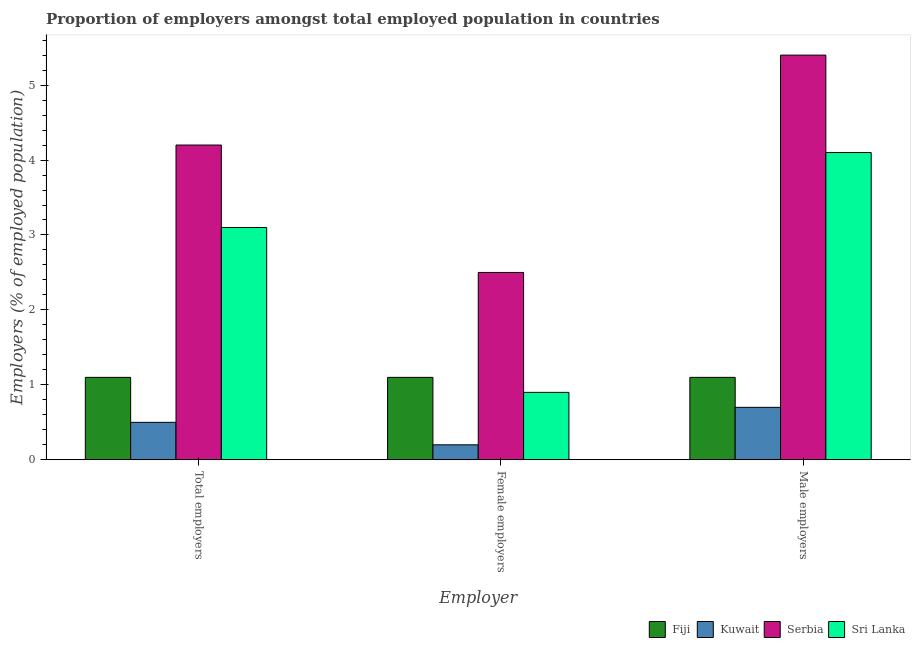How many groups of bars are there?
Your response must be concise. 3. Are the number of bars on each tick of the X-axis equal?
Offer a terse response. Yes. How many bars are there on the 2nd tick from the left?
Provide a succinct answer. 4. How many bars are there on the 1st tick from the right?
Offer a terse response. 4. What is the label of the 2nd group of bars from the left?
Your response must be concise. Female employers. What is the percentage of female employers in Sri Lanka?
Your answer should be very brief. 0.9. Across all countries, what is the minimum percentage of female employers?
Ensure brevity in your answer.  0.2. In which country was the percentage of male employers maximum?
Provide a succinct answer. Serbia. In which country was the percentage of total employers minimum?
Your answer should be compact. Kuwait. What is the total percentage of male employers in the graph?
Ensure brevity in your answer.  11.3. What is the difference between the percentage of female employers in Kuwait and that in Sri Lanka?
Offer a very short reply. -0.7. What is the difference between the percentage of female employers in Fiji and the percentage of male employers in Serbia?
Provide a succinct answer. -4.3. What is the average percentage of total employers per country?
Your answer should be compact. 2.22. What is the difference between the percentage of total employers and percentage of female employers in Fiji?
Offer a very short reply. 0. In how many countries, is the percentage of male employers greater than 1.4 %?
Give a very brief answer. 2. What is the ratio of the percentage of total employers in Serbia to that in Sri Lanka?
Offer a terse response. 1.35. Is the percentage of female employers in Fiji less than that in Serbia?
Your response must be concise. Yes. What is the difference between the highest and the second highest percentage of female employers?
Offer a very short reply. 1.4. What is the difference between the highest and the lowest percentage of female employers?
Keep it short and to the point. 2.3. Is the sum of the percentage of total employers in Serbia and Kuwait greater than the maximum percentage of male employers across all countries?
Your answer should be compact. No. What does the 1st bar from the left in Male employers represents?
Provide a short and direct response. Fiji. What does the 3rd bar from the right in Total employers represents?
Your answer should be very brief. Kuwait. Are all the bars in the graph horizontal?
Your answer should be very brief. No. How many countries are there in the graph?
Your answer should be very brief. 4. What is the difference between two consecutive major ticks on the Y-axis?
Offer a very short reply. 1. Are the values on the major ticks of Y-axis written in scientific E-notation?
Your answer should be compact. No. Does the graph contain any zero values?
Offer a terse response. No. Does the graph contain grids?
Offer a terse response. No. How are the legend labels stacked?
Provide a succinct answer. Horizontal. What is the title of the graph?
Your response must be concise. Proportion of employers amongst total employed population in countries. What is the label or title of the X-axis?
Provide a short and direct response. Employer. What is the label or title of the Y-axis?
Offer a very short reply. Employers (% of employed population). What is the Employers (% of employed population) in Fiji in Total employers?
Provide a succinct answer. 1.1. What is the Employers (% of employed population) in Kuwait in Total employers?
Offer a terse response. 0.5. What is the Employers (% of employed population) in Serbia in Total employers?
Ensure brevity in your answer.  4.2. What is the Employers (% of employed population) in Sri Lanka in Total employers?
Keep it short and to the point. 3.1. What is the Employers (% of employed population) in Fiji in Female employers?
Offer a terse response. 1.1. What is the Employers (% of employed population) in Kuwait in Female employers?
Provide a succinct answer. 0.2. What is the Employers (% of employed population) of Serbia in Female employers?
Offer a terse response. 2.5. What is the Employers (% of employed population) in Sri Lanka in Female employers?
Your answer should be compact. 0.9. What is the Employers (% of employed population) of Fiji in Male employers?
Offer a terse response. 1.1. What is the Employers (% of employed population) of Kuwait in Male employers?
Your answer should be compact. 0.7. What is the Employers (% of employed population) of Serbia in Male employers?
Your answer should be compact. 5.4. What is the Employers (% of employed population) in Sri Lanka in Male employers?
Give a very brief answer. 4.1. Across all Employer, what is the maximum Employers (% of employed population) in Fiji?
Your answer should be very brief. 1.1. Across all Employer, what is the maximum Employers (% of employed population) of Kuwait?
Give a very brief answer. 0.7. Across all Employer, what is the maximum Employers (% of employed population) of Serbia?
Offer a very short reply. 5.4. Across all Employer, what is the maximum Employers (% of employed population) of Sri Lanka?
Your answer should be compact. 4.1. Across all Employer, what is the minimum Employers (% of employed population) in Fiji?
Your response must be concise. 1.1. Across all Employer, what is the minimum Employers (% of employed population) in Kuwait?
Provide a succinct answer. 0.2. Across all Employer, what is the minimum Employers (% of employed population) of Sri Lanka?
Keep it short and to the point. 0.9. What is the total Employers (% of employed population) of Fiji in the graph?
Give a very brief answer. 3.3. What is the total Employers (% of employed population) in Kuwait in the graph?
Your response must be concise. 1.4. What is the difference between the Employers (% of employed population) of Kuwait in Total employers and that in Female employers?
Your answer should be compact. 0.3. What is the difference between the Employers (% of employed population) in Fiji in Total employers and that in Male employers?
Ensure brevity in your answer.  0. What is the difference between the Employers (% of employed population) in Sri Lanka in Total employers and that in Male employers?
Provide a short and direct response. -1. What is the difference between the Employers (% of employed population) of Fiji in Total employers and the Employers (% of employed population) of Kuwait in Female employers?
Your answer should be very brief. 0.9. What is the difference between the Employers (% of employed population) in Fiji in Total employers and the Employers (% of employed population) in Sri Lanka in Female employers?
Provide a succinct answer. 0.2. What is the difference between the Employers (% of employed population) in Kuwait in Total employers and the Employers (% of employed population) in Sri Lanka in Female employers?
Give a very brief answer. -0.4. What is the difference between the Employers (% of employed population) of Serbia in Total employers and the Employers (% of employed population) of Sri Lanka in Female employers?
Offer a very short reply. 3.3. What is the difference between the Employers (% of employed population) in Kuwait in Total employers and the Employers (% of employed population) in Sri Lanka in Male employers?
Offer a terse response. -3.6. What is the difference between the Employers (% of employed population) of Serbia in Total employers and the Employers (% of employed population) of Sri Lanka in Male employers?
Your answer should be very brief. 0.1. What is the difference between the Employers (% of employed population) of Fiji in Female employers and the Employers (% of employed population) of Kuwait in Male employers?
Keep it short and to the point. 0.4. What is the difference between the Employers (% of employed population) of Fiji in Female employers and the Employers (% of employed population) of Serbia in Male employers?
Make the answer very short. -4.3. What is the difference between the Employers (% of employed population) in Fiji in Female employers and the Employers (% of employed population) in Sri Lanka in Male employers?
Your answer should be very brief. -3. What is the difference between the Employers (% of employed population) of Kuwait in Female employers and the Employers (% of employed population) of Serbia in Male employers?
Your answer should be very brief. -5.2. What is the average Employers (% of employed population) in Kuwait per Employer?
Provide a short and direct response. 0.47. What is the average Employers (% of employed population) of Serbia per Employer?
Ensure brevity in your answer.  4.03. What is the average Employers (% of employed population) of Sri Lanka per Employer?
Make the answer very short. 2.7. What is the difference between the Employers (% of employed population) of Fiji and Employers (% of employed population) of Kuwait in Total employers?
Keep it short and to the point. 0.6. What is the difference between the Employers (% of employed population) in Fiji and Employers (% of employed population) in Sri Lanka in Total employers?
Keep it short and to the point. -2. What is the difference between the Employers (% of employed population) of Kuwait and Employers (% of employed population) of Sri Lanka in Total employers?
Provide a short and direct response. -2.6. What is the difference between the Employers (% of employed population) of Serbia and Employers (% of employed population) of Sri Lanka in Total employers?
Keep it short and to the point. 1.1. What is the difference between the Employers (% of employed population) in Fiji and Employers (% of employed population) in Sri Lanka in Female employers?
Your answer should be very brief. 0.2. What is the difference between the Employers (% of employed population) in Kuwait and Employers (% of employed population) in Sri Lanka in Female employers?
Your answer should be very brief. -0.7. What is the difference between the Employers (% of employed population) in Serbia and Employers (% of employed population) in Sri Lanka in Female employers?
Your response must be concise. 1.6. What is the difference between the Employers (% of employed population) in Fiji and Employers (% of employed population) in Serbia in Male employers?
Give a very brief answer. -4.3. What is the difference between the Employers (% of employed population) of Fiji and Employers (% of employed population) of Sri Lanka in Male employers?
Offer a terse response. -3. What is the difference between the Employers (% of employed population) of Kuwait and Employers (% of employed population) of Serbia in Male employers?
Make the answer very short. -4.7. What is the ratio of the Employers (% of employed population) of Serbia in Total employers to that in Female employers?
Your answer should be very brief. 1.68. What is the ratio of the Employers (% of employed population) in Sri Lanka in Total employers to that in Female employers?
Your answer should be compact. 3.44. What is the ratio of the Employers (% of employed population) in Fiji in Total employers to that in Male employers?
Keep it short and to the point. 1. What is the ratio of the Employers (% of employed population) of Kuwait in Total employers to that in Male employers?
Ensure brevity in your answer.  0.71. What is the ratio of the Employers (% of employed population) of Sri Lanka in Total employers to that in Male employers?
Your answer should be very brief. 0.76. What is the ratio of the Employers (% of employed population) of Kuwait in Female employers to that in Male employers?
Keep it short and to the point. 0.29. What is the ratio of the Employers (% of employed population) of Serbia in Female employers to that in Male employers?
Provide a succinct answer. 0.46. What is the ratio of the Employers (% of employed population) in Sri Lanka in Female employers to that in Male employers?
Give a very brief answer. 0.22. What is the difference between the highest and the second highest Employers (% of employed population) in Serbia?
Provide a succinct answer. 1.2. What is the difference between the highest and the second highest Employers (% of employed population) of Sri Lanka?
Offer a very short reply. 1. What is the difference between the highest and the lowest Employers (% of employed population) of Fiji?
Your answer should be compact. 0. What is the difference between the highest and the lowest Employers (% of employed population) of Serbia?
Ensure brevity in your answer.  2.9. What is the difference between the highest and the lowest Employers (% of employed population) of Sri Lanka?
Offer a terse response. 3.2. 